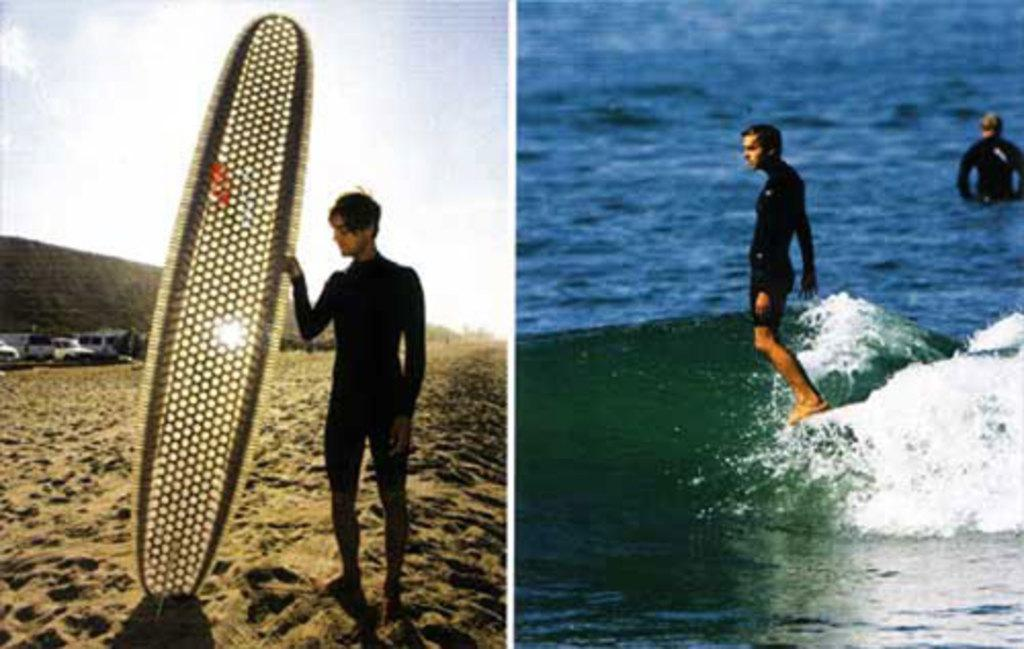What is the person holding in the image? The fact does not specify what the person is holding, so we cannot definitively answer this question. What activity is the other person engaged in? The other person is surfing in the image. How many lizards can be seen crawling on the surfboard in the image? There are no lizards present in the image. 